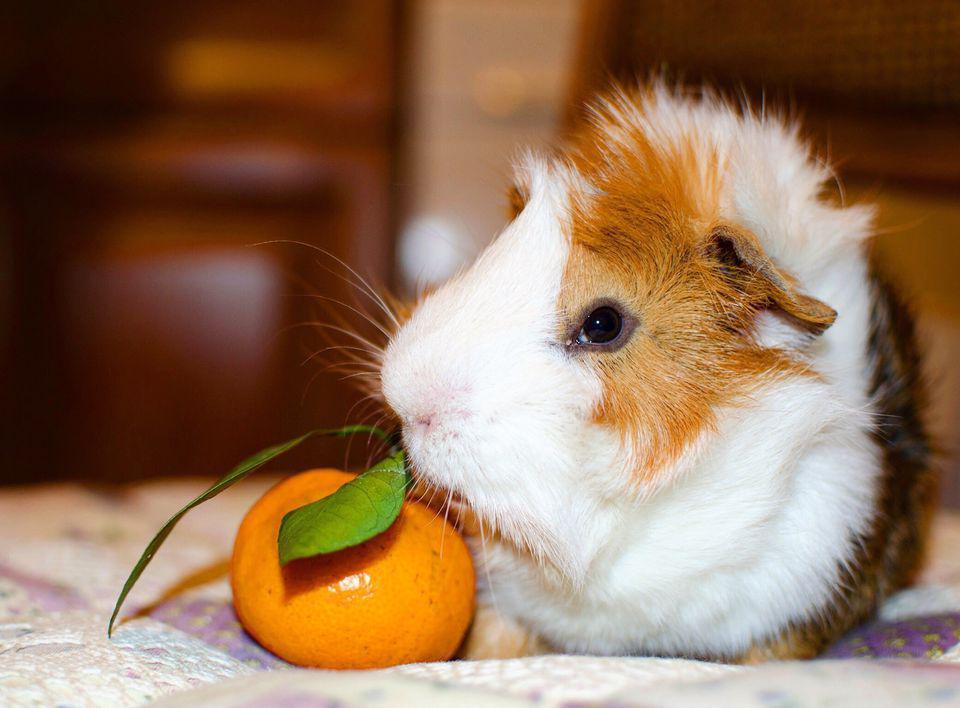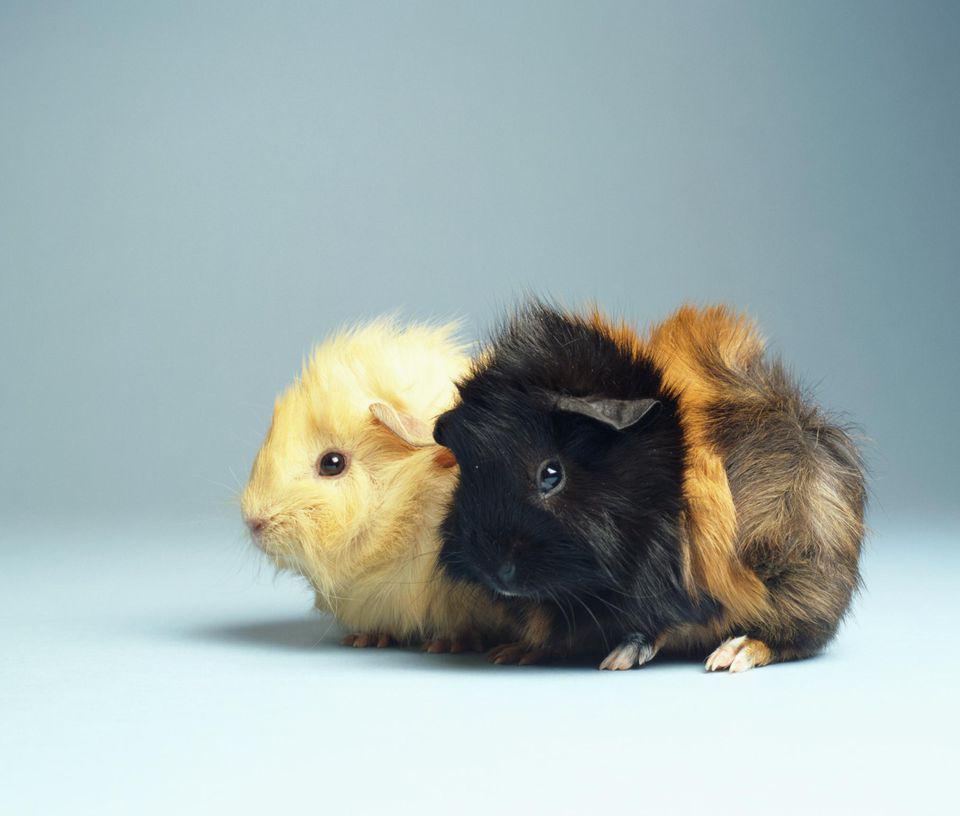The first image is the image on the left, the second image is the image on the right. Evaluate the accuracy of this statement regarding the images: "One of the images includes part of a human.". Is it true? Answer yes or no. No. The first image is the image on the left, the second image is the image on the right. Analyze the images presented: Is the assertion "In one image there are two guinea pigs eating grass." valid? Answer yes or no. No. 